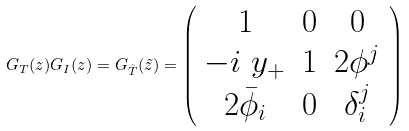Convert formula to latex. <formula><loc_0><loc_0><loc_500><loc_500>G _ { T } ( z ) G _ { I } ( z ) = G _ { \tilde { T } } ( \tilde { z } ) = \left ( \begin{array} { c c c } 1 & 0 & 0 \\ - i \ y _ { + } & 1 & 2 \phi ^ { j } \\ 2 \bar { \phi } _ { i } & 0 & \delta _ { i } ^ { j } \end{array} \right )</formula> 